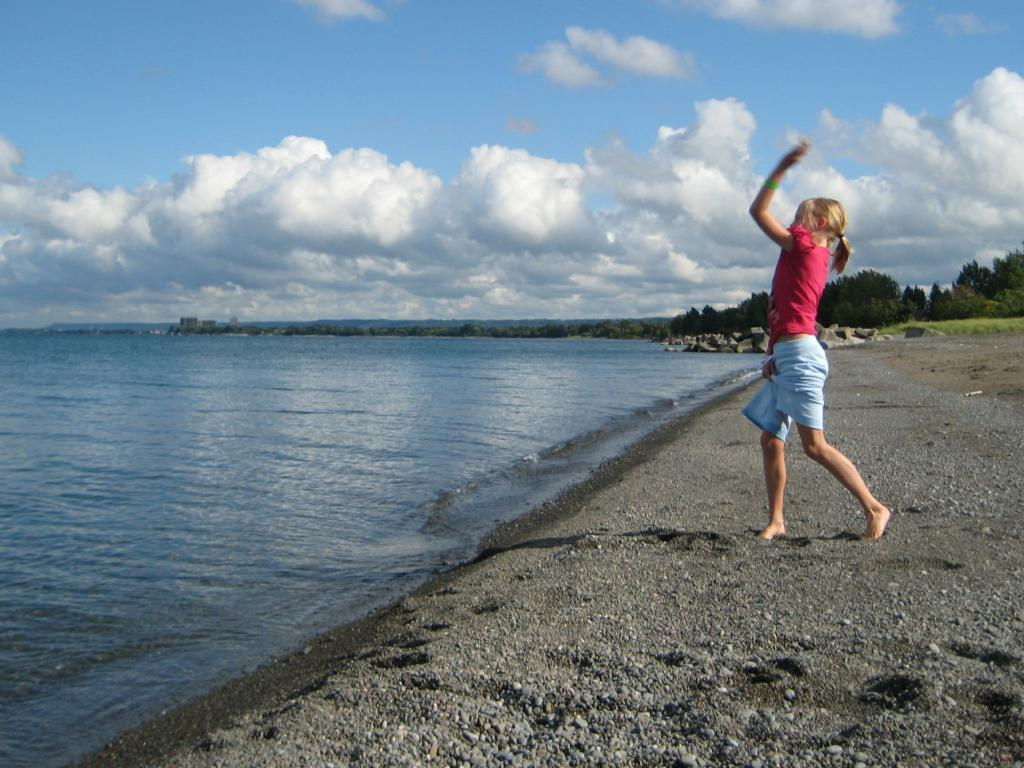What is the main subject of the image? There is a person standing in the image. What is the person standing on? The person is standing on a surface. What natural element can be seen in the image? There is water visible in the image. What type of vegetation is on the right side of the image? There are trees on the right side of the image. What is visible in the sky in the image? Clouds are present in the sky. What type of bomb can be seen in the image? There is no bomb present in the image. Can you hear the horse in the image? There is no horse present in the image, so it cannot be heard. 